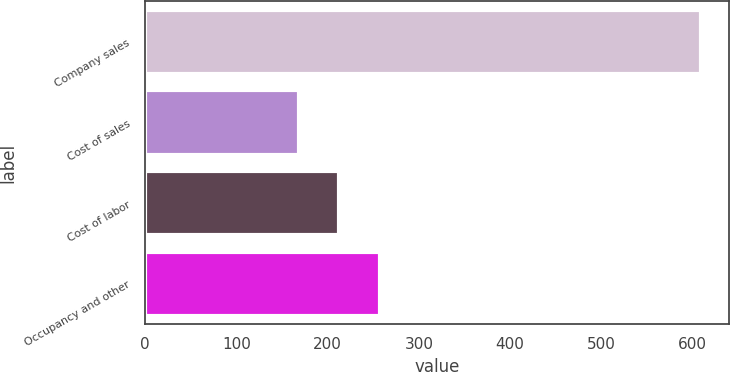Convert chart to OTSL. <chart><loc_0><loc_0><loc_500><loc_500><bar_chart><fcel>Company sales<fcel>Cost of sales<fcel>Cost of labor<fcel>Occupancy and other<nl><fcel>609<fcel>169<fcel>213<fcel>257<nl></chart> 